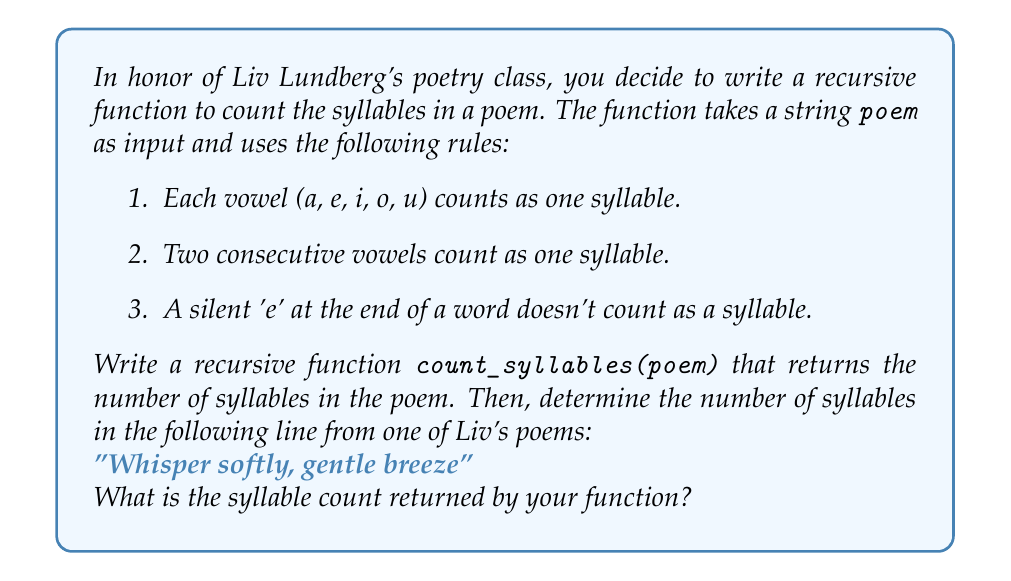Show me your answer to this math problem. Let's break down the problem and implement the recursive function:

1. Base case: If the poem is empty, return 0.
2. Recursive case: Count the syllables in the first word and add it to the syllables in the rest of the poem.

Here's the Python implementation of the recursive function:

```python
def count_syllables(poem):
    if not poem:
        return 0
    
    words = poem.split()
    if not words:
        return 0
    
    first_word = words[0].lower()
    rest_of_poem = ' '.join(words[1:])
    
    return count_word_syllables(first_word) + count_syllables(rest_of_poem)

def count_word_syllables(word):
    vowels = 'aeiou'
    count = 0
    prev_char = ''
    
    for i, char in enumerate(word):
        if char in vowels:
            if prev_char not in vowels:
                count += 1
        prev_char = char
    
    if word.endswith('e') and len(word) > 1 and word[-2] not in vowels:
        count -= 1
    
    return max(1, count)
```

Now, let's apply this function to the given line:

"Whisper softly, gentle breeze"

1. "Whisper" -> 2 syllables (whis-per)
2. "softly" -> 2 syllables (soft-ly)
3. "gentle" -> 2 syllables (gen-tle)
4. "breeze" -> 1 syllable (breeze)

The total syllable count is: 2 + 2 + 2 + 1 = 7
Answer: 7 